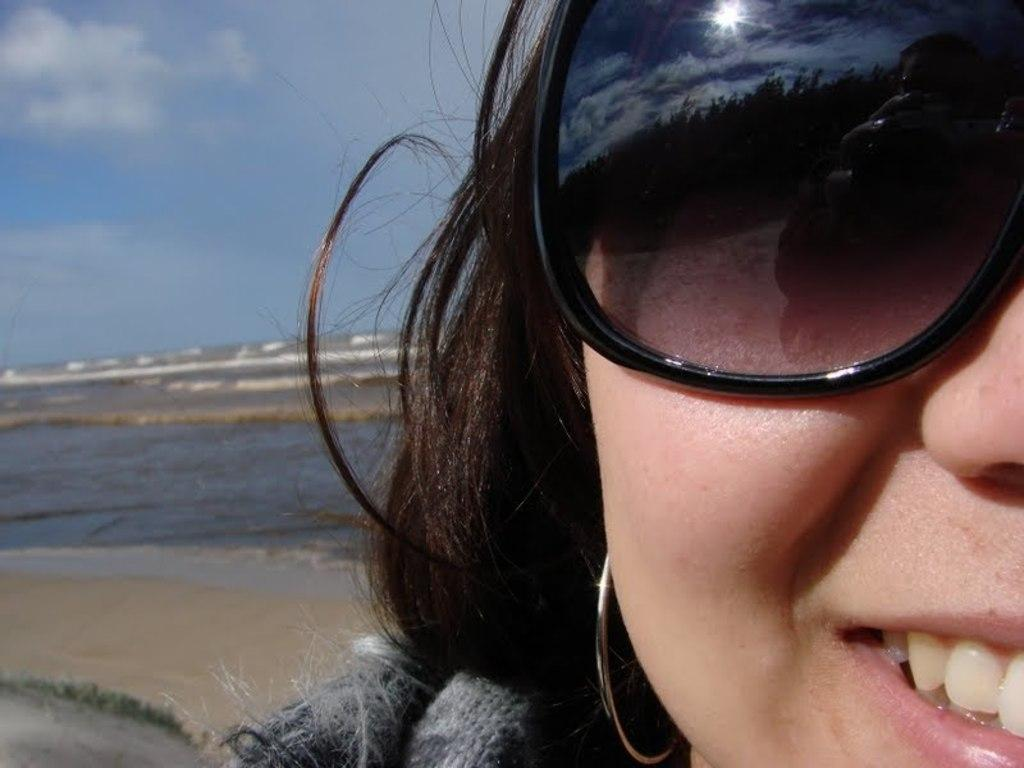Who is present in the image? There is a woman in the image. What is the woman wearing? The woman is wearing a dress and goggles. What is the woman's position in the image? The woman is standing on the ground. What can be seen in the background of the image? There is water and a cloudy sky visible in the background. What type of house is depicted in the image? There is no house depicted in the image; it features a woman standing on the ground with water and a cloudy sky in the background. 